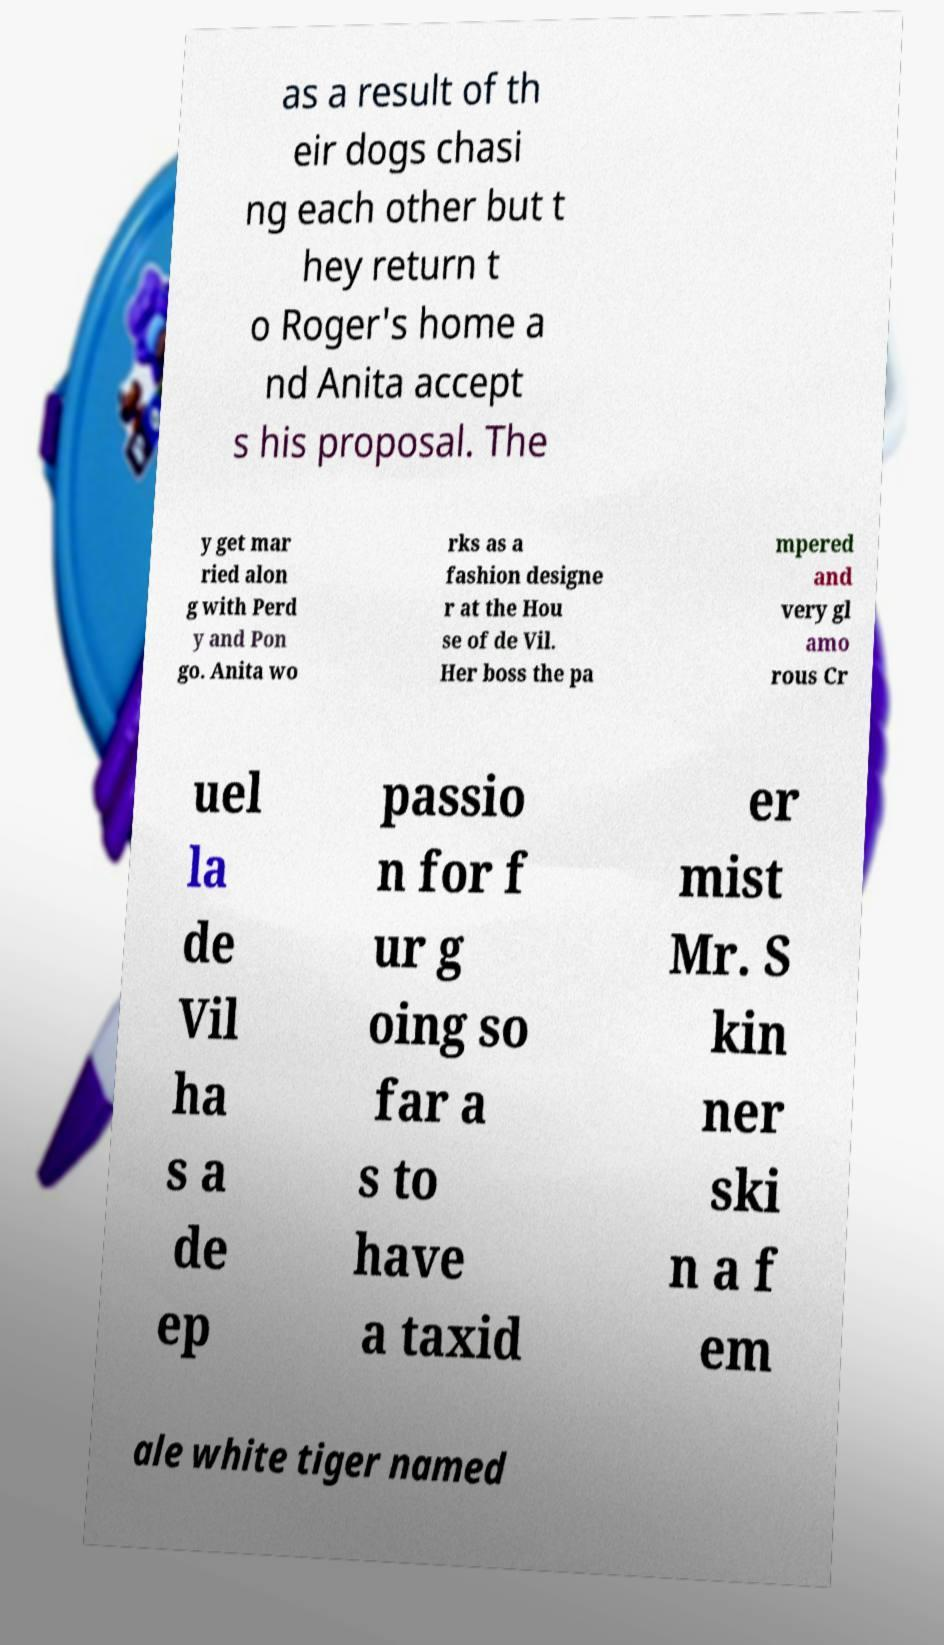I need the written content from this picture converted into text. Can you do that? as a result of th eir dogs chasi ng each other but t hey return t o Roger's home a nd Anita accept s his proposal. The y get mar ried alon g with Perd y and Pon go. Anita wo rks as a fashion designe r at the Hou se of de Vil. Her boss the pa mpered and very gl amo rous Cr uel la de Vil ha s a de ep passio n for f ur g oing so far a s to have a taxid er mist Mr. S kin ner ski n a f em ale white tiger named 